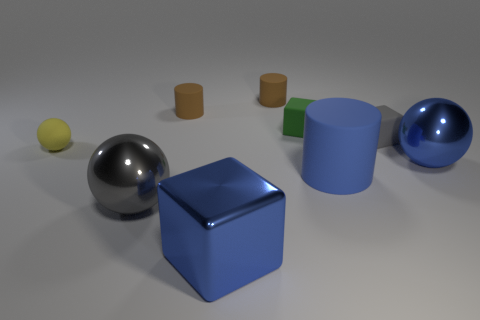There is a rubber cylinder in front of the tiny ball; does it have the same color as the block in front of the yellow rubber ball?
Provide a short and direct response. Yes. Is the number of big matte objects greater than the number of big purple spheres?
Your answer should be compact. Yes. How many other rubber blocks are the same color as the large block?
Provide a succinct answer. 0. There is another rubber thing that is the same shape as the gray matte object; what color is it?
Ensure brevity in your answer.  Green. There is a sphere that is both to the left of the gray block and right of the matte ball; what material is it?
Give a very brief answer. Metal. Are the brown cylinder that is to the right of the large blue cube and the large blue thing that is in front of the large gray metal sphere made of the same material?
Give a very brief answer. No. What size is the gray ball?
Make the answer very short. Large. There is a yellow matte thing that is the same shape as the large gray metal object; what size is it?
Your response must be concise. Small. What number of small green rubber things are in front of the matte ball?
Give a very brief answer. 0. There is a object to the right of the gray object behind the yellow matte ball; what color is it?
Provide a succinct answer. Blue. 